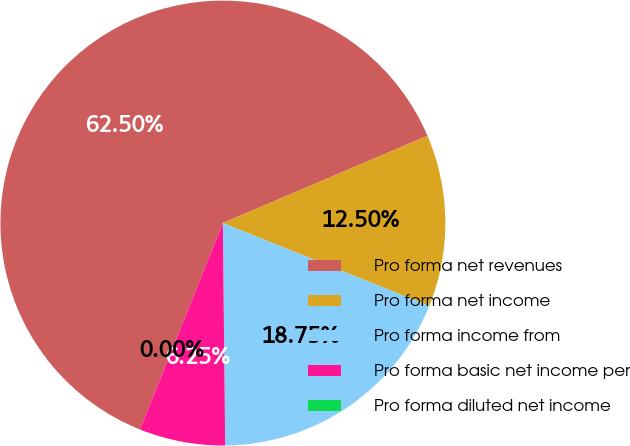Convert chart to OTSL. <chart><loc_0><loc_0><loc_500><loc_500><pie_chart><fcel>Pro forma net revenues<fcel>Pro forma net income<fcel>Pro forma income from<fcel>Pro forma basic net income per<fcel>Pro forma diluted net income<nl><fcel>62.5%<fcel>12.5%<fcel>18.75%<fcel>6.25%<fcel>0.0%<nl></chart> 